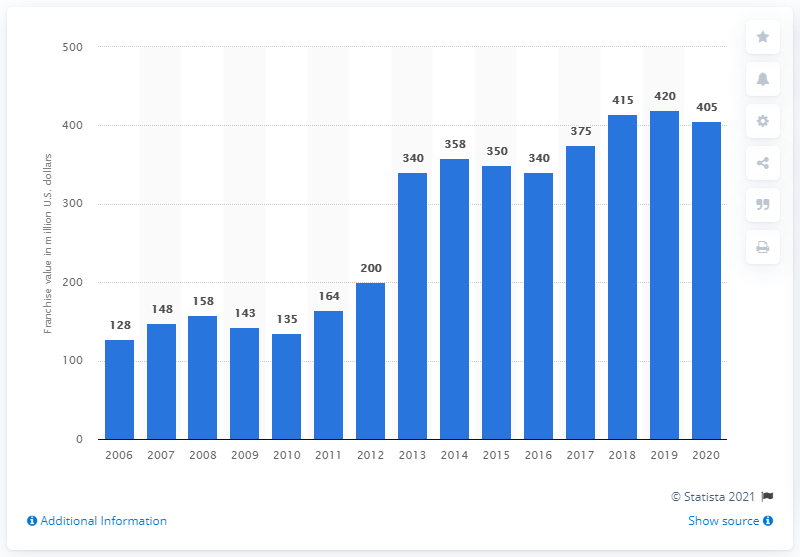Specify some key components in this picture. The estimated value of the Winnipeg Jets in 2020 was approximately 405 million dollars. 